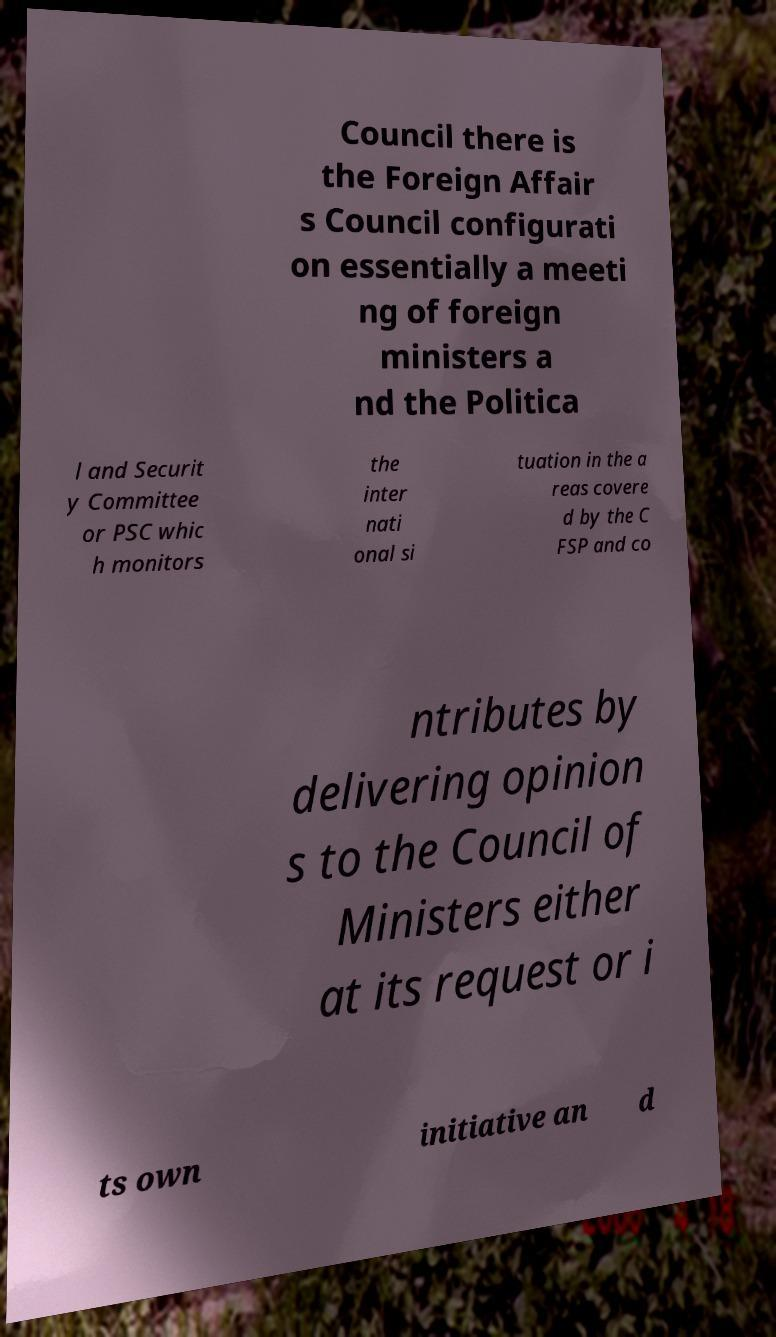Can you accurately transcribe the text from the provided image for me? Council there is the Foreign Affair s Council configurati on essentially a meeti ng of foreign ministers a nd the Politica l and Securit y Committee or PSC whic h monitors the inter nati onal si tuation in the a reas covere d by the C FSP and co ntributes by delivering opinion s to the Council of Ministers either at its request or i ts own initiative an d 